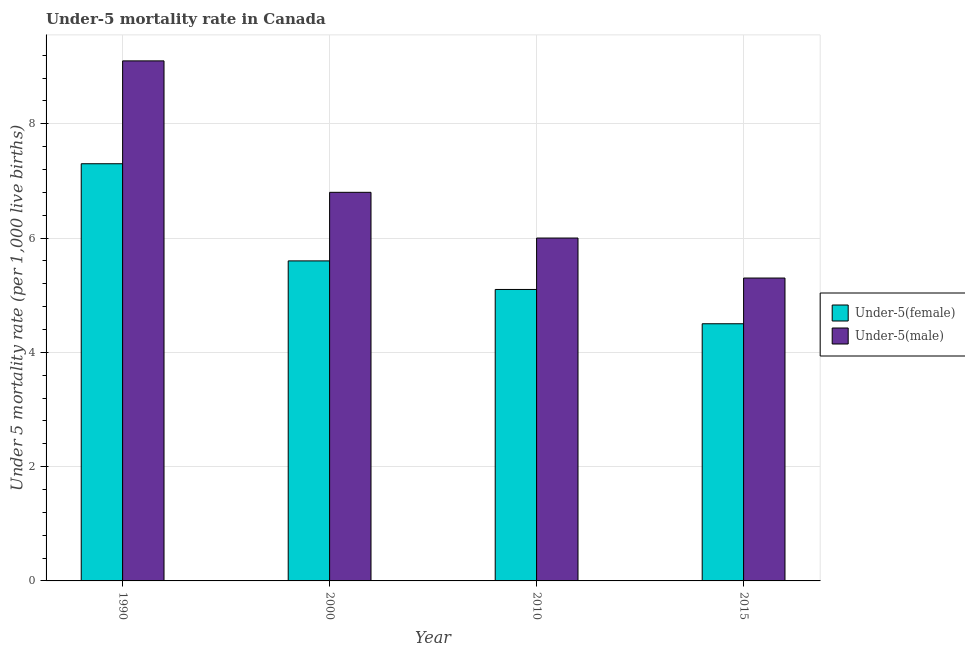How many groups of bars are there?
Your answer should be compact. 4. Are the number of bars per tick equal to the number of legend labels?
Give a very brief answer. Yes. How many bars are there on the 1st tick from the left?
Keep it short and to the point. 2. How many bars are there on the 4th tick from the right?
Offer a very short reply. 2. What is the label of the 4th group of bars from the left?
Your answer should be compact. 2015. In which year was the under-5 male mortality rate maximum?
Give a very brief answer. 1990. In which year was the under-5 female mortality rate minimum?
Make the answer very short. 2015. What is the total under-5 male mortality rate in the graph?
Your answer should be very brief. 27.2. What is the difference between the under-5 male mortality rate in 1990 and that in 2000?
Ensure brevity in your answer.  2.3. What is the difference between the under-5 male mortality rate in 1990 and the under-5 female mortality rate in 2010?
Give a very brief answer. 3.1. What is the ratio of the under-5 female mortality rate in 2000 to that in 2010?
Provide a short and direct response. 1.1. Is the under-5 female mortality rate in 2000 less than that in 2010?
Keep it short and to the point. No. Is the difference between the under-5 female mortality rate in 1990 and 2000 greater than the difference between the under-5 male mortality rate in 1990 and 2000?
Provide a short and direct response. No. What is the difference between the highest and the second highest under-5 female mortality rate?
Offer a terse response. 1.7. What is the difference between the highest and the lowest under-5 female mortality rate?
Make the answer very short. 2.8. In how many years, is the under-5 female mortality rate greater than the average under-5 female mortality rate taken over all years?
Your answer should be compact. 1. Is the sum of the under-5 female mortality rate in 1990 and 2010 greater than the maximum under-5 male mortality rate across all years?
Offer a very short reply. Yes. What does the 2nd bar from the left in 2000 represents?
Offer a very short reply. Under-5(male). What does the 2nd bar from the right in 2000 represents?
Make the answer very short. Under-5(female). How many years are there in the graph?
Make the answer very short. 4. Does the graph contain grids?
Keep it short and to the point. Yes. How are the legend labels stacked?
Give a very brief answer. Vertical. What is the title of the graph?
Offer a very short reply. Under-5 mortality rate in Canada. Does "RDB nonconcessional" appear as one of the legend labels in the graph?
Ensure brevity in your answer.  No. What is the label or title of the X-axis?
Offer a very short reply. Year. What is the label or title of the Y-axis?
Ensure brevity in your answer.  Under 5 mortality rate (per 1,0 live births). What is the Under 5 mortality rate (per 1,000 live births) in Under-5(female) in 2015?
Provide a succinct answer. 4.5. What is the Under 5 mortality rate (per 1,000 live births) in Under-5(male) in 2015?
Offer a very short reply. 5.3. Across all years, what is the maximum Under 5 mortality rate (per 1,000 live births) in Under-5(female)?
Your response must be concise. 7.3. Across all years, what is the maximum Under 5 mortality rate (per 1,000 live births) of Under-5(male)?
Make the answer very short. 9.1. Across all years, what is the minimum Under 5 mortality rate (per 1,000 live births) in Under-5(female)?
Provide a succinct answer. 4.5. Across all years, what is the minimum Under 5 mortality rate (per 1,000 live births) in Under-5(male)?
Make the answer very short. 5.3. What is the total Under 5 mortality rate (per 1,000 live births) of Under-5(female) in the graph?
Your answer should be very brief. 22.5. What is the total Under 5 mortality rate (per 1,000 live births) in Under-5(male) in the graph?
Provide a short and direct response. 27.2. What is the difference between the Under 5 mortality rate (per 1,000 live births) in Under-5(male) in 1990 and that in 2000?
Provide a succinct answer. 2.3. What is the difference between the Under 5 mortality rate (per 1,000 live births) in Under-5(female) in 1990 and that in 2015?
Ensure brevity in your answer.  2.8. What is the difference between the Under 5 mortality rate (per 1,000 live births) of Under-5(male) in 1990 and that in 2015?
Your answer should be very brief. 3.8. What is the difference between the Under 5 mortality rate (per 1,000 live births) in Under-5(female) in 2000 and that in 2015?
Offer a terse response. 1.1. What is the difference between the Under 5 mortality rate (per 1,000 live births) in Under-5(male) in 2000 and that in 2015?
Your response must be concise. 1.5. What is the difference between the Under 5 mortality rate (per 1,000 live births) of Under-5(male) in 2010 and that in 2015?
Provide a succinct answer. 0.7. What is the average Under 5 mortality rate (per 1,000 live births) in Under-5(female) per year?
Provide a succinct answer. 5.62. In the year 2000, what is the difference between the Under 5 mortality rate (per 1,000 live births) of Under-5(female) and Under 5 mortality rate (per 1,000 live births) of Under-5(male)?
Provide a succinct answer. -1.2. In the year 2010, what is the difference between the Under 5 mortality rate (per 1,000 live births) in Under-5(female) and Under 5 mortality rate (per 1,000 live births) in Under-5(male)?
Ensure brevity in your answer.  -0.9. What is the ratio of the Under 5 mortality rate (per 1,000 live births) of Under-5(female) in 1990 to that in 2000?
Provide a succinct answer. 1.3. What is the ratio of the Under 5 mortality rate (per 1,000 live births) in Under-5(male) in 1990 to that in 2000?
Make the answer very short. 1.34. What is the ratio of the Under 5 mortality rate (per 1,000 live births) in Under-5(female) in 1990 to that in 2010?
Make the answer very short. 1.43. What is the ratio of the Under 5 mortality rate (per 1,000 live births) of Under-5(male) in 1990 to that in 2010?
Ensure brevity in your answer.  1.52. What is the ratio of the Under 5 mortality rate (per 1,000 live births) of Under-5(female) in 1990 to that in 2015?
Give a very brief answer. 1.62. What is the ratio of the Under 5 mortality rate (per 1,000 live births) of Under-5(male) in 1990 to that in 2015?
Your answer should be compact. 1.72. What is the ratio of the Under 5 mortality rate (per 1,000 live births) of Under-5(female) in 2000 to that in 2010?
Your response must be concise. 1.1. What is the ratio of the Under 5 mortality rate (per 1,000 live births) in Under-5(male) in 2000 to that in 2010?
Your answer should be compact. 1.13. What is the ratio of the Under 5 mortality rate (per 1,000 live births) in Under-5(female) in 2000 to that in 2015?
Give a very brief answer. 1.24. What is the ratio of the Under 5 mortality rate (per 1,000 live births) in Under-5(male) in 2000 to that in 2015?
Provide a short and direct response. 1.28. What is the ratio of the Under 5 mortality rate (per 1,000 live births) in Under-5(female) in 2010 to that in 2015?
Make the answer very short. 1.13. What is the ratio of the Under 5 mortality rate (per 1,000 live births) in Under-5(male) in 2010 to that in 2015?
Your response must be concise. 1.13. What is the difference between the highest and the second highest Under 5 mortality rate (per 1,000 live births) of Under-5(male)?
Make the answer very short. 2.3. What is the difference between the highest and the lowest Under 5 mortality rate (per 1,000 live births) of Under-5(female)?
Ensure brevity in your answer.  2.8. What is the difference between the highest and the lowest Under 5 mortality rate (per 1,000 live births) of Under-5(male)?
Offer a terse response. 3.8. 